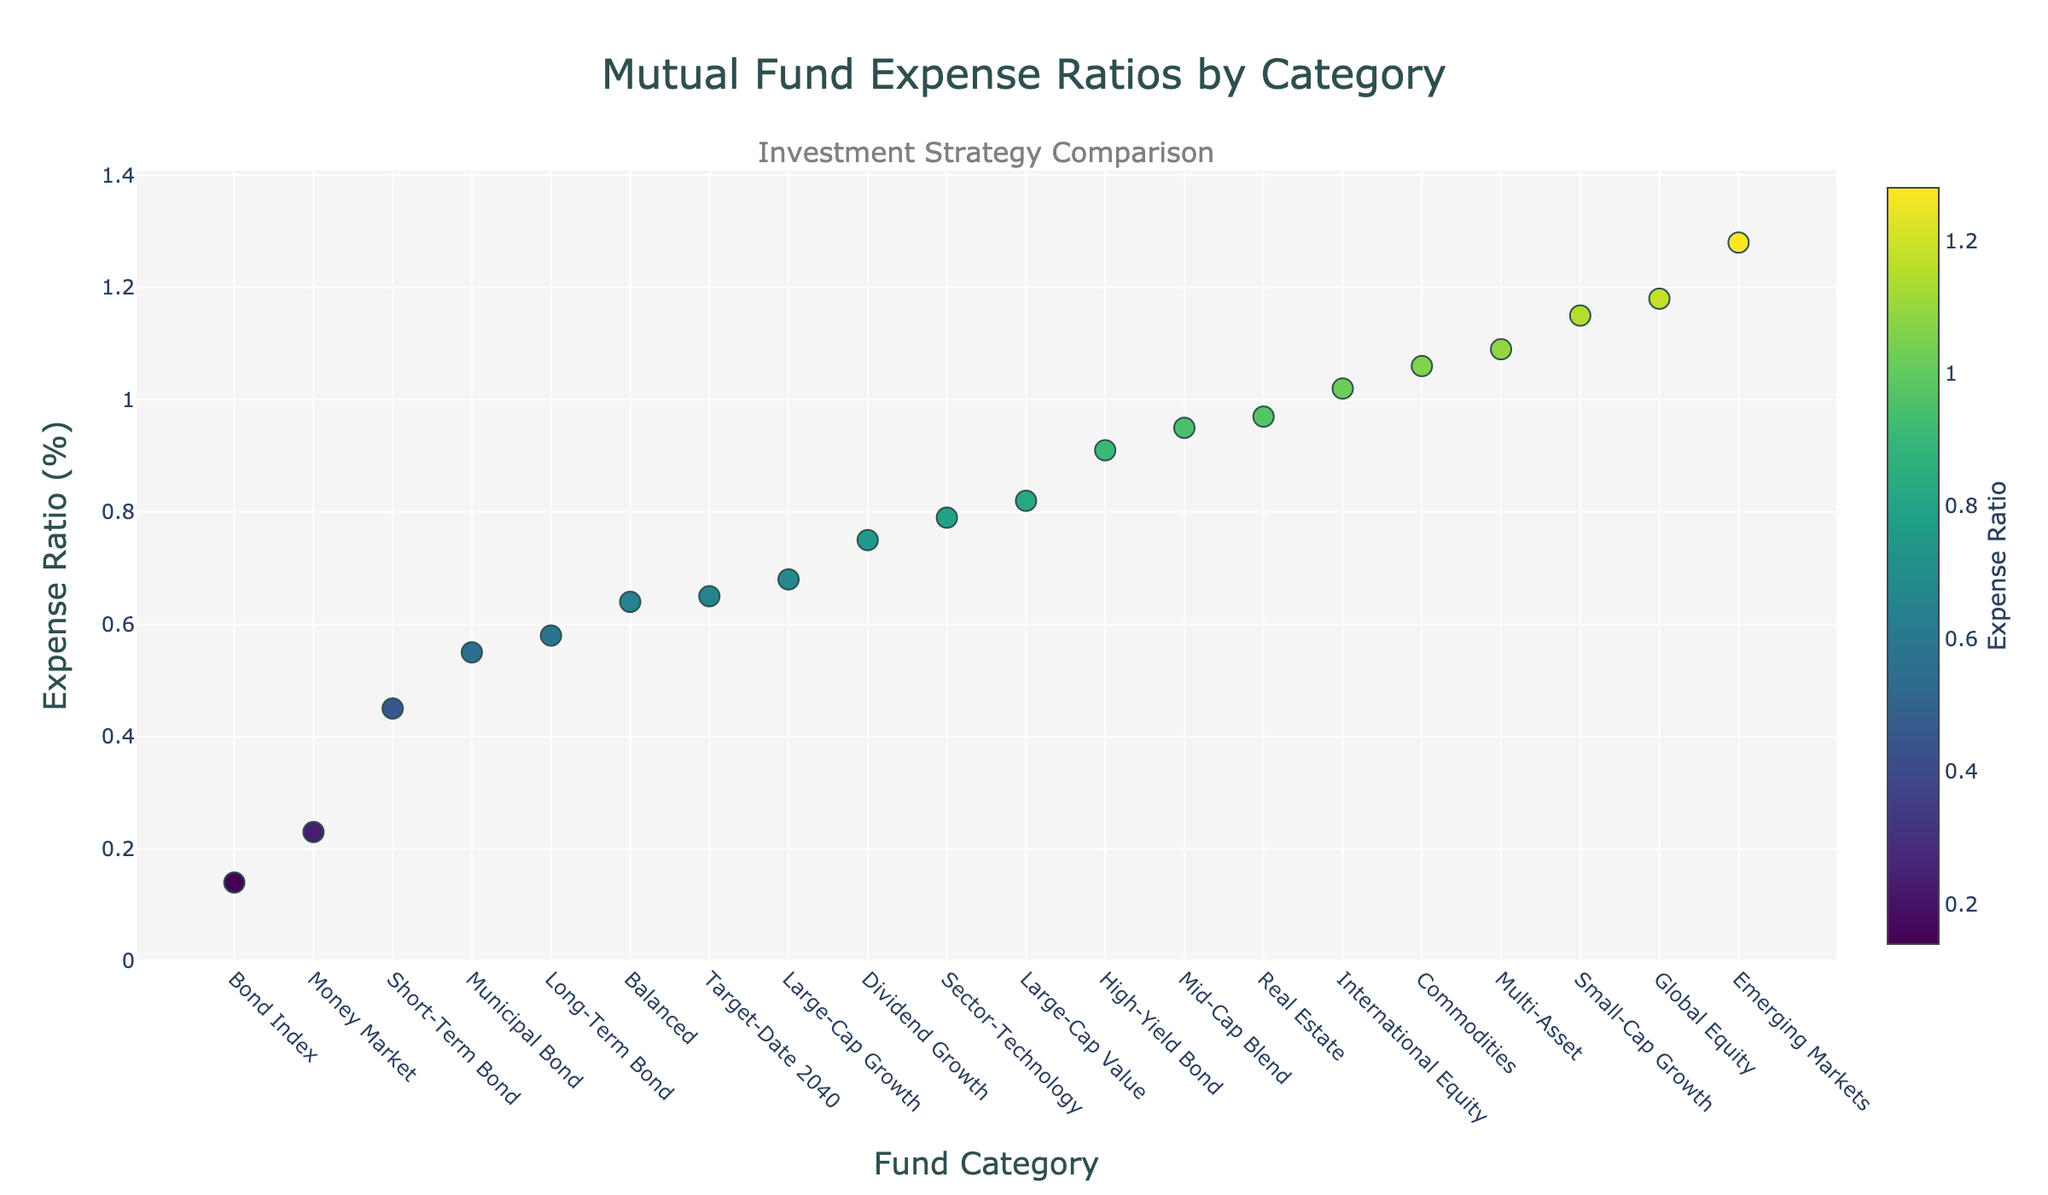What is the title of the plot? The title is located at the top of the plot and provides the summary of the visual. The title here is "Mutual Fund Expense Ratios by Category".
Answer: Mutual Fund Expense Ratios by Category Which category has the highest expense ratio? Look for the highest data point on the vertical axis (Expense Ratio) to determine the category. The highest point corresponds to "Emerging Markets" with an expense ratio of 1.28%.
Answer: Emerging Markets What is the lowest expense ratio displayed, and for which category? Identify the lowest point on the vertical axis (Expense Ratio). The lowest expense ratio is 0.14%, and it corresponds to the "Bond Index" category.
Answer: Bond Index How many categories have an expense ratio below 0.5? To find the number of categories below 0.5, observe the y-axis and count the markers below this threshold. The relevant categories are Bond Index, Money Market, Short-Term Bond, and Municipal Bond. This totals to 4 categories.
Answer: 4 What is the range of expense ratios represented in this plot? The range is calculated by subtracting the smallest expense ratio from the largest expense ratio. The smallest value is 0.14% (Bond Index), and the largest is 1.28% (Emerging Markets). Hence the range is 1.28% - 0.14% = 1.14%.
Answer: 1.14% How do the expense ratios for Large-Cap Growth and Large-Cap Value compare to Target-Date 2040? First, locate the data points for "Large-Cap Growth", "Large-Cap Value", and "Target-Date 2040". The ratios are 0.68% for Large-Cap Growth, 0.82% for Large-Cap Value, and 0.65% for Target-Date 2040. Both Large-Cap Growth and Large-Cap Value have higher expense ratios than Target-Date 2040.
Answer: Higher than Target-Date 2040 What is the median expense ratio of all categories displayed? List all expense ratios in ascending order: [0.14, 0.23, 0.45, 0.55, 0.58, 0.64, 0.65, 0.68, 0.75, 0.79, 0.82, 0.91, 0.95, 0.97, 1.02, 1.06, 1.09, 1.15, 1.18, 1.28]. There are 20 values, so the median is the average of the 10th and 11th values (0.79 and 0.82). The median expense ratio is (0.79 + 0.82)/2 = 0.805%.
Answer: 0.805% Which category has an expense ratio closest to the average expense ratio? First, compute the average expense ratio by summing all values and dividing by the number of categories: (0.14 + 0.23 + 0.45 + 0.55 + 0.58 + 0.64 + 0.65 + 0.68 + 0.75 + 0.79 + 0.82 + 0.91 + 0.95 + 0.97 + 1.02 + 1.06 + 1.09 + 1.15 + 1.18 + 1.28)/20 ≈ 0.806%. Then find the closest category value, which is "Dividend Growth" with an expense ratio of 0.75%.
Answer: Dividend Growth Which categories fall into the top quartile of expense ratios? The top quartile consists of the top 25% of the data points. With 20 categories, the top quartile includes the top 5 values. These are: 1.28% (Emerging Markets), 1.18% (Global Equity), 1.15% (Small-Cap Growth), 1.09% (Multi-Asset), and 1.06% (Commodities).
Answer: Emerging Markets, Global Equity, Small-Cap Growth, Multi-Asset, Commodities 